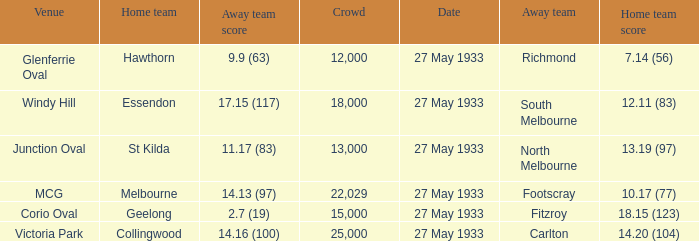In the match where the home team scored 14.20 (104), how many attendees were in the crowd? 25000.0. 